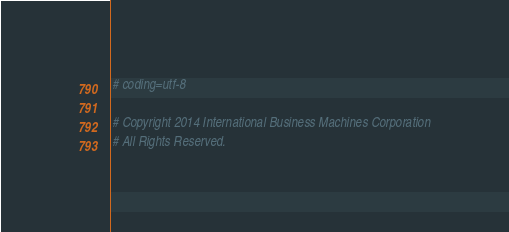Convert code to text. <code><loc_0><loc_0><loc_500><loc_500><_Python_># coding=utf-8

# Copyright 2014 International Business Machines Corporation
# All Rights Reserved.</code> 